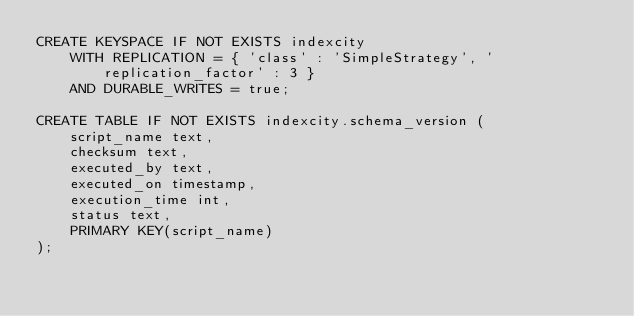Convert code to text. <code><loc_0><loc_0><loc_500><loc_500><_SQL_>CREATE KEYSPACE IF NOT EXISTS indexcity
    WITH REPLICATION = { 'class' : 'SimpleStrategy', 'replication_factor' : 3 }
    AND DURABLE_WRITES = true;

CREATE TABLE IF NOT EXISTS indexcity.schema_version (
    script_name text,
    checksum text,
    executed_by text,
    executed_on timestamp,
    execution_time int,
    status text,
    PRIMARY KEY(script_name)
);
</code> 